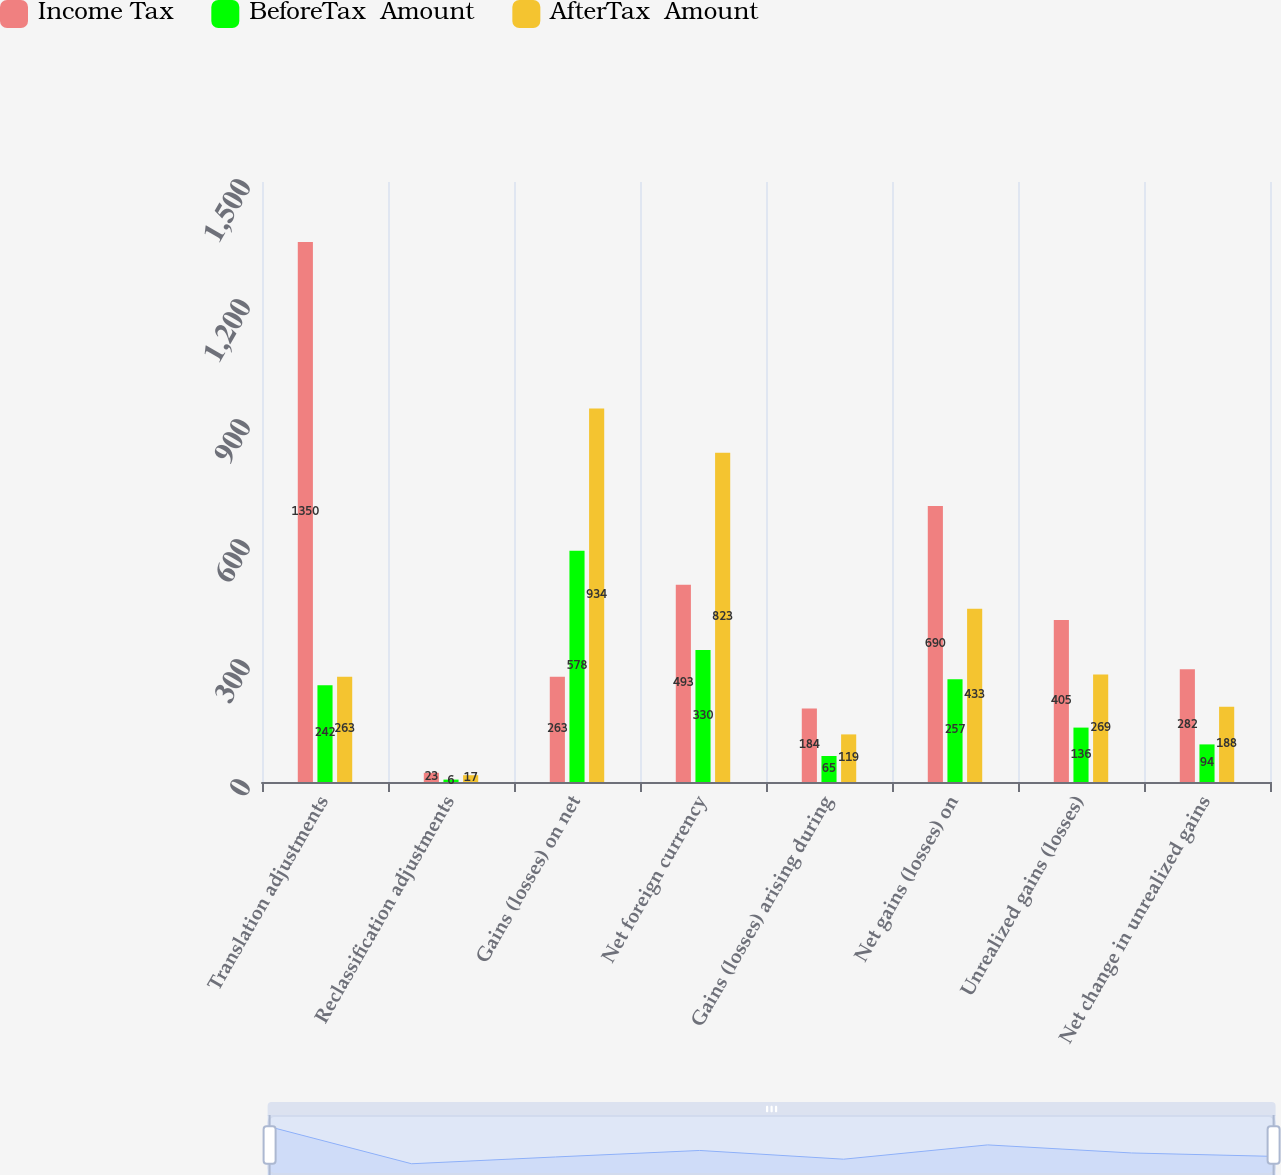Convert chart. <chart><loc_0><loc_0><loc_500><loc_500><stacked_bar_chart><ecel><fcel>Translation adjustments<fcel>Reclassification adjustments<fcel>Gains (losses) on net<fcel>Net foreign currency<fcel>Gains (losses) arising during<fcel>Net gains (losses) on<fcel>Unrealized gains (losses)<fcel>Net change in unrealized gains<nl><fcel>Income Tax<fcel>1350<fcel>23<fcel>263<fcel>493<fcel>184<fcel>690<fcel>405<fcel>282<nl><fcel>BeforeTax  Amount<fcel>242<fcel>6<fcel>578<fcel>330<fcel>65<fcel>257<fcel>136<fcel>94<nl><fcel>AfterTax  Amount<fcel>263<fcel>17<fcel>934<fcel>823<fcel>119<fcel>433<fcel>269<fcel>188<nl></chart> 